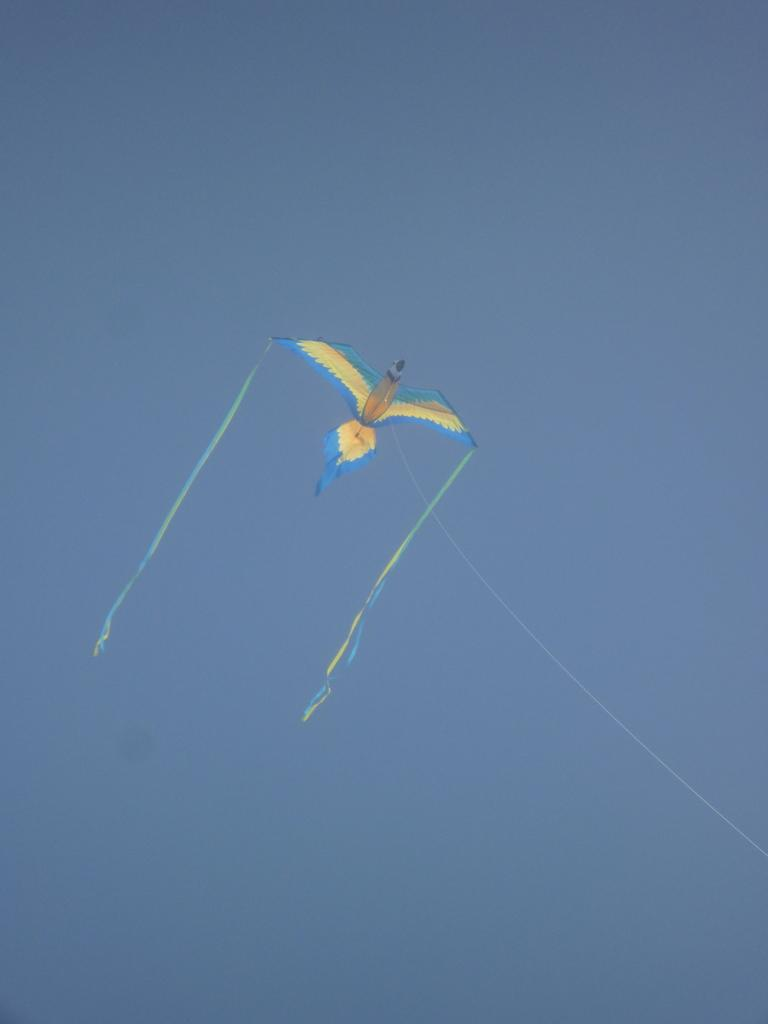What is the main subject of the image? The main subject of the image is a kite. What shape is the kite in the image? The kite is in the shape of a bird. What can be seen in the background of the image? The sky is visible in the background of the image. How does the kite express its dislike for the bird in the image? The kite does not express any emotions or dislikes in the image, as it is an inanimate object. 